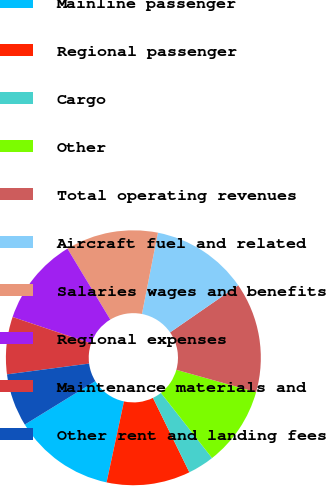<chart> <loc_0><loc_0><loc_500><loc_500><pie_chart><fcel>Mainline passenger<fcel>Regional passenger<fcel>Cargo<fcel>Other<fcel>Total operating revenues<fcel>Aircraft fuel and related<fcel>Salaries wages and benefits<fcel>Regional expenses<fcel>Maintenance materials and<fcel>Other rent and landing fees<nl><fcel>12.85%<fcel>10.61%<fcel>3.35%<fcel>10.06%<fcel>13.97%<fcel>12.29%<fcel>11.73%<fcel>11.17%<fcel>7.26%<fcel>6.7%<nl></chart> 